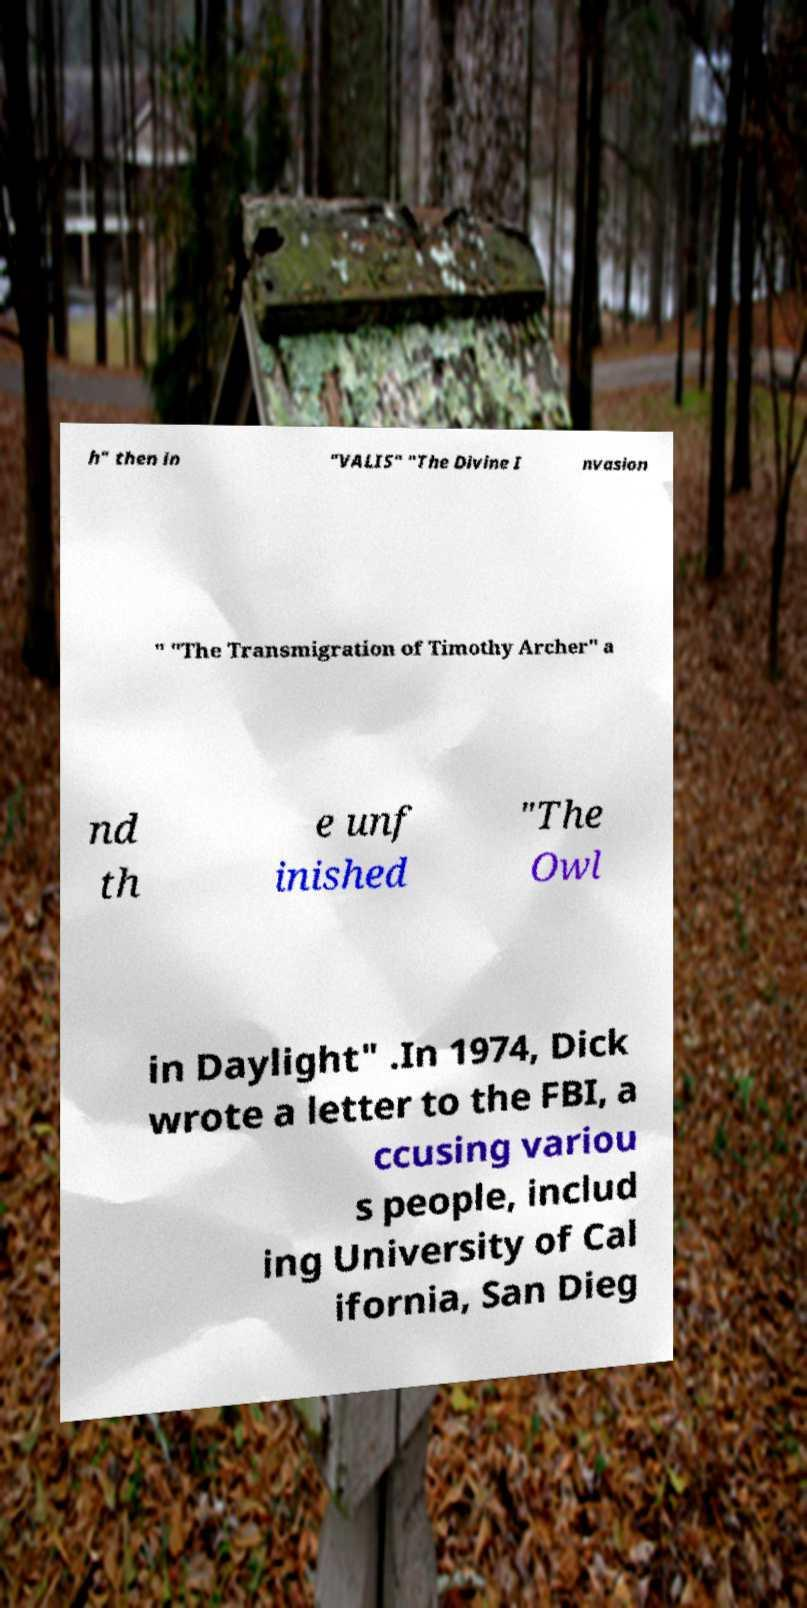Please identify and transcribe the text found in this image. h" then in "VALIS" "The Divine I nvasion " "The Transmigration of Timothy Archer" a nd th e unf inished "The Owl in Daylight" .In 1974, Dick wrote a letter to the FBI, a ccusing variou s people, includ ing University of Cal ifornia, San Dieg 